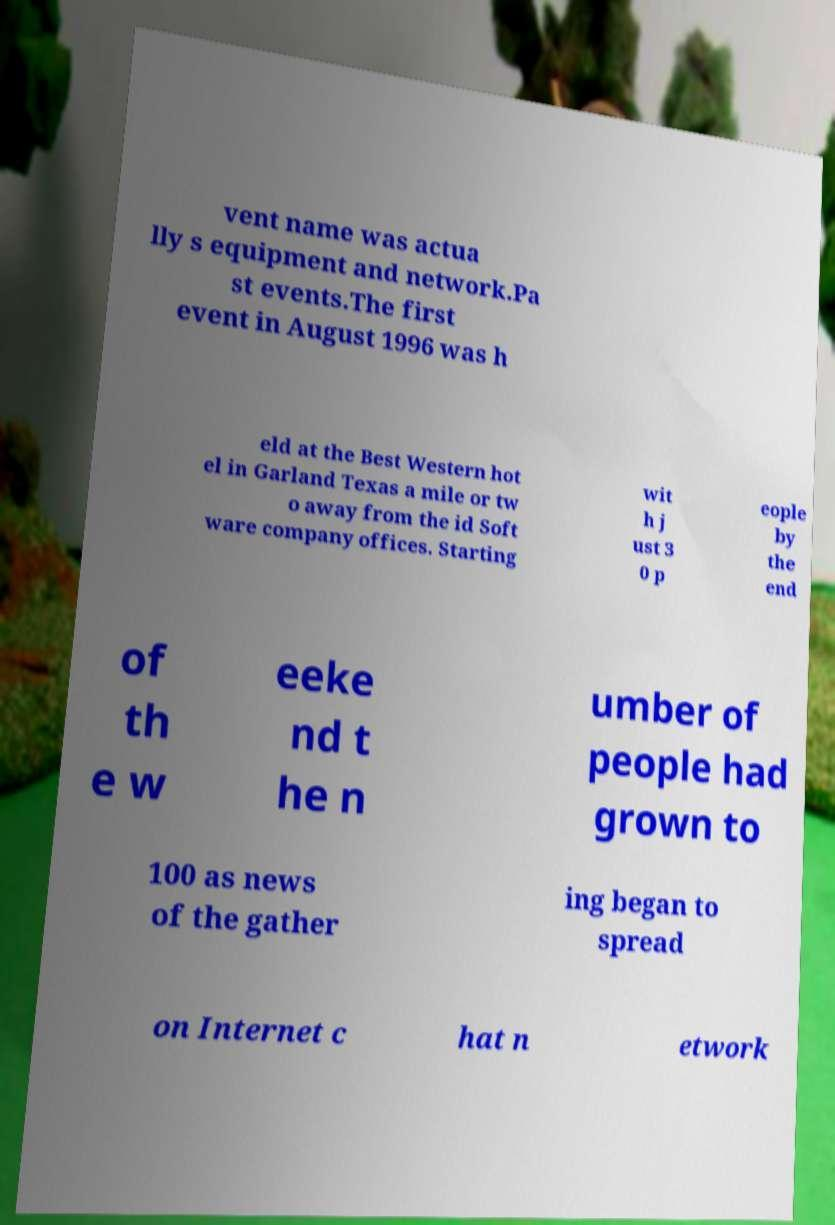Please identify and transcribe the text found in this image. vent name was actua lly s equipment and network.Pa st events.The first event in August 1996 was h eld at the Best Western hot el in Garland Texas a mile or tw o away from the id Soft ware company offices. Starting wit h j ust 3 0 p eople by the end of th e w eeke nd t he n umber of people had grown to 100 as news of the gather ing began to spread on Internet c hat n etwork 